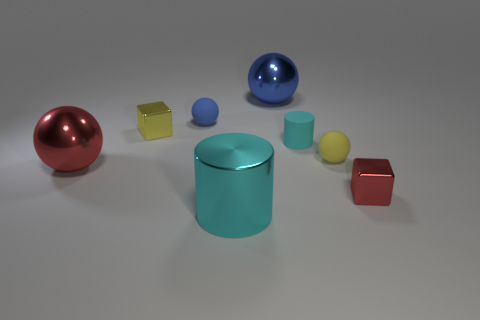The small matte thing that is the same color as the big cylinder is what shape?
Keep it short and to the point. Cylinder. There is a shiny block on the left side of the yellow rubber object; how many shiny balls are behind it?
Give a very brief answer. 1. What is the size of the sphere that is both in front of the small blue matte object and to the left of the cyan metal thing?
Your answer should be compact. Large. Is there a blue metal object of the same size as the shiny cylinder?
Offer a terse response. Yes. Is the number of tiny things that are on the left side of the tiny blue rubber ball greater than the number of cyan metallic objects behind the small yellow metal thing?
Keep it short and to the point. Yes. Does the big cyan cylinder have the same material as the cyan object behind the big cyan shiny object?
Keep it short and to the point. No. There is a small ball behind the tiny metal cube that is to the left of the red block; what number of small matte spheres are in front of it?
Provide a short and direct response. 1. There is a large cyan object; does it have the same shape as the small metallic thing to the right of the blue metallic object?
Your answer should be compact. No. There is a large shiny thing that is both in front of the yellow block and to the right of the small yellow metal thing; what is its color?
Provide a short and direct response. Cyan. The blue thing that is on the left side of the big shiny thing behind the metal sphere that is on the left side of the big cylinder is made of what material?
Offer a very short reply. Rubber. 